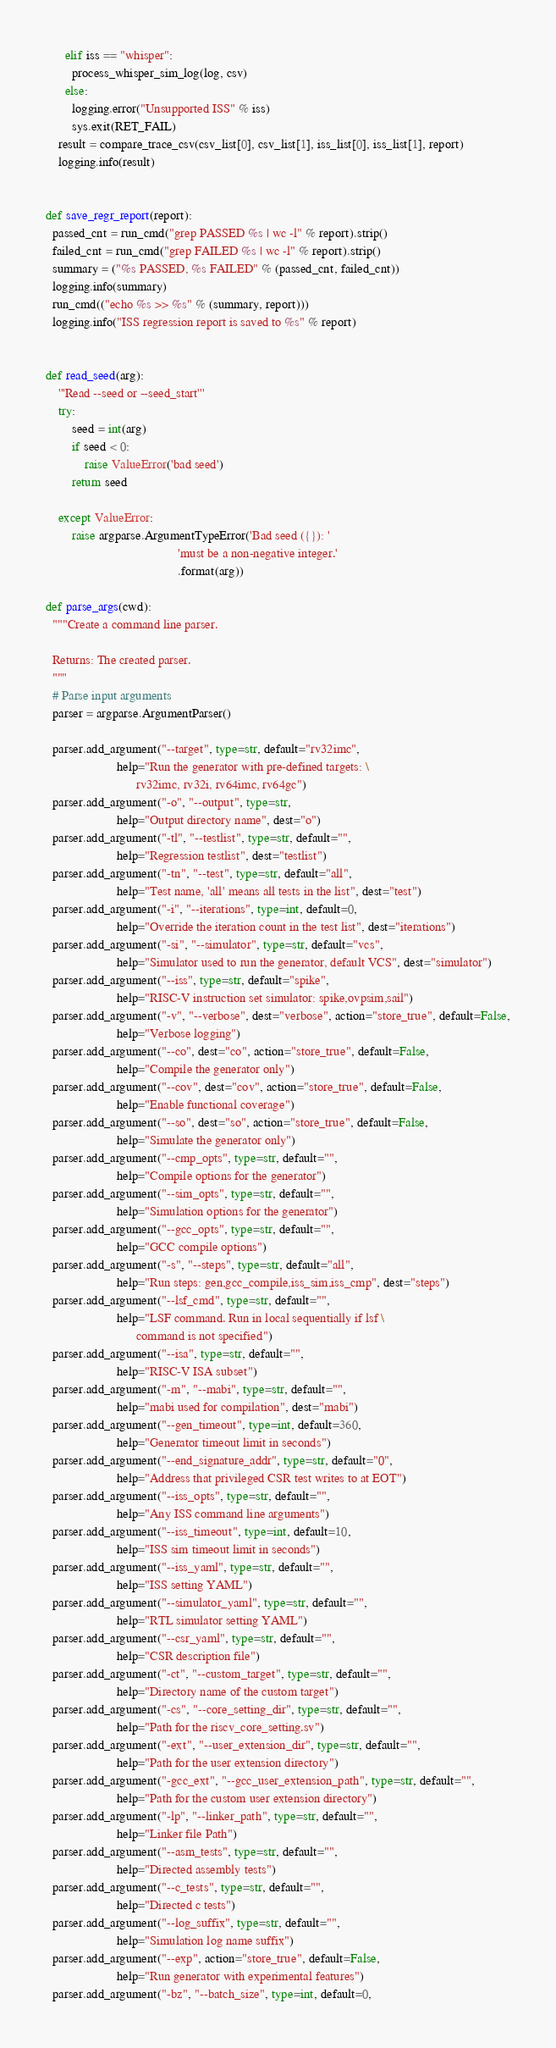Convert code to text. <code><loc_0><loc_0><loc_500><loc_500><_Python_>      elif iss == "whisper":
        process_whisper_sim_log(log, csv)
      else:
        logging.error("Unsupported ISS" % iss)
        sys.exit(RET_FAIL)
    result = compare_trace_csv(csv_list[0], csv_list[1], iss_list[0], iss_list[1], report)
    logging.info(result)


def save_regr_report(report):
  passed_cnt = run_cmd("grep PASSED %s | wc -l" % report).strip()
  failed_cnt = run_cmd("grep FAILED %s | wc -l" % report).strip()
  summary = ("%s PASSED, %s FAILED" % (passed_cnt, failed_cnt))
  logging.info(summary)
  run_cmd(("echo %s >> %s" % (summary, report)))
  logging.info("ISS regression report is saved to %s" % report)


def read_seed(arg):
    '''Read --seed or --seed_start'''
    try:
        seed = int(arg)
        if seed < 0:
            raise ValueError('bad seed')
        return seed

    except ValueError:
        raise argparse.ArgumentTypeError('Bad seed ({}): '
                                         'must be a non-negative integer.'
                                         .format(arg))

def parse_args(cwd):
  """Create a command line parser.

  Returns: The created parser.
  """
  # Parse input arguments
  parser = argparse.ArgumentParser()

  parser.add_argument("--target", type=str, default="rv32imc",
                      help="Run the generator with pre-defined targets: \
                            rv32imc, rv32i, rv64imc, rv64gc")
  parser.add_argument("-o", "--output", type=str,
                      help="Output directory name", dest="o")
  parser.add_argument("-tl", "--testlist", type=str, default="",
                      help="Regression testlist", dest="testlist")
  parser.add_argument("-tn", "--test", type=str, default="all",
                      help="Test name, 'all' means all tests in the list", dest="test")
  parser.add_argument("-i", "--iterations", type=int, default=0,
                      help="Override the iteration count in the test list", dest="iterations")
  parser.add_argument("-si", "--simulator", type=str, default="vcs",
                      help="Simulator used to run the generator, default VCS", dest="simulator")
  parser.add_argument("--iss", type=str, default="spike",
                      help="RISC-V instruction set simulator: spike,ovpsim,sail")
  parser.add_argument("-v", "--verbose", dest="verbose", action="store_true", default=False,
                      help="Verbose logging")
  parser.add_argument("--co", dest="co", action="store_true", default=False,
                      help="Compile the generator only")
  parser.add_argument("--cov", dest="cov", action="store_true", default=False,
                      help="Enable functional coverage")
  parser.add_argument("--so", dest="so", action="store_true", default=False,
                      help="Simulate the generator only")
  parser.add_argument("--cmp_opts", type=str, default="",
                      help="Compile options for the generator")
  parser.add_argument("--sim_opts", type=str, default="",
                      help="Simulation options for the generator")
  parser.add_argument("--gcc_opts", type=str, default="",
                      help="GCC compile options")
  parser.add_argument("-s", "--steps", type=str, default="all",
                      help="Run steps: gen,gcc_compile,iss_sim,iss_cmp", dest="steps")
  parser.add_argument("--lsf_cmd", type=str, default="",
                      help="LSF command. Run in local sequentially if lsf \
                            command is not specified")
  parser.add_argument("--isa", type=str, default="",
                      help="RISC-V ISA subset")
  parser.add_argument("-m", "--mabi", type=str, default="",
                      help="mabi used for compilation", dest="mabi")
  parser.add_argument("--gen_timeout", type=int, default=360,
                      help="Generator timeout limit in seconds")
  parser.add_argument("--end_signature_addr", type=str, default="0",
                      help="Address that privileged CSR test writes to at EOT")
  parser.add_argument("--iss_opts", type=str, default="",
                      help="Any ISS command line arguments")
  parser.add_argument("--iss_timeout", type=int, default=10,
                      help="ISS sim timeout limit in seconds")
  parser.add_argument("--iss_yaml", type=str, default="",
                      help="ISS setting YAML")
  parser.add_argument("--simulator_yaml", type=str, default="",
                      help="RTL simulator setting YAML")
  parser.add_argument("--csr_yaml", type=str, default="",
                      help="CSR description file")
  parser.add_argument("-ct", "--custom_target", type=str, default="",
                      help="Directory name of the custom target")
  parser.add_argument("-cs", "--core_setting_dir", type=str, default="",
                      help="Path for the riscv_core_setting.sv")
  parser.add_argument("-ext", "--user_extension_dir", type=str, default="",
                      help="Path for the user extension directory")
  parser.add_argument("-gcc_ext", "--gcc_user_extension_path", type=str, default="",
                      help="Path for the custom user extension directory")
  parser.add_argument("-lp", "--linker_path", type=str, default="",
  					  help="Linker file Path")
  parser.add_argument("--asm_tests", type=str, default="",
                      help="Directed assembly tests")
  parser.add_argument("--c_tests", type=str, default="",
                      help="Directed c tests")
  parser.add_argument("--log_suffix", type=str, default="",
                      help="Simulation log name suffix")
  parser.add_argument("--exp", action="store_true", default=False,
                      help="Run generator with experimental features")
  parser.add_argument("-bz", "--batch_size", type=int, default=0,</code> 